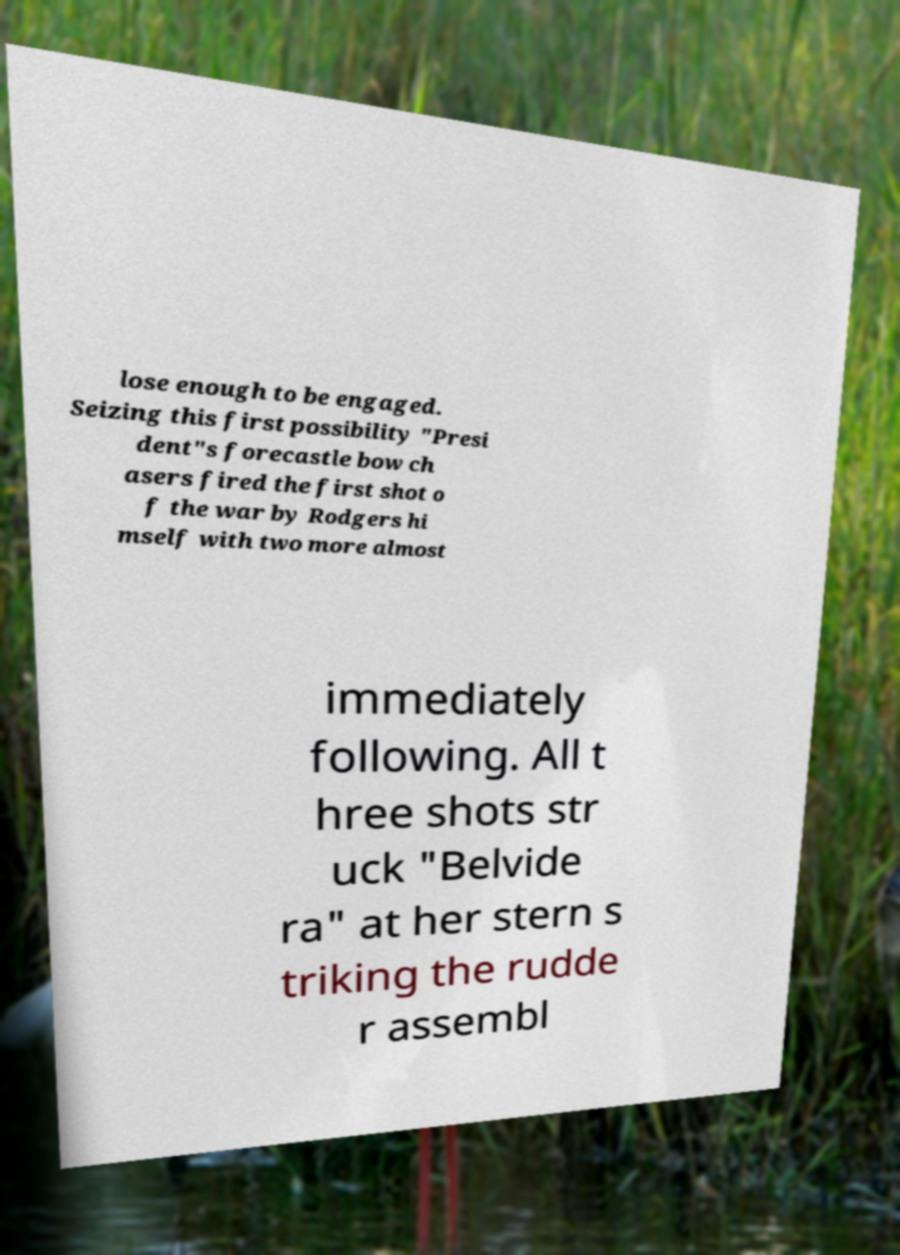Please read and relay the text visible in this image. What does it say? lose enough to be engaged. Seizing this first possibility "Presi dent"s forecastle bow ch asers fired the first shot o f the war by Rodgers hi mself with two more almost immediately following. All t hree shots str uck "Belvide ra" at her stern s triking the rudde r assembl 